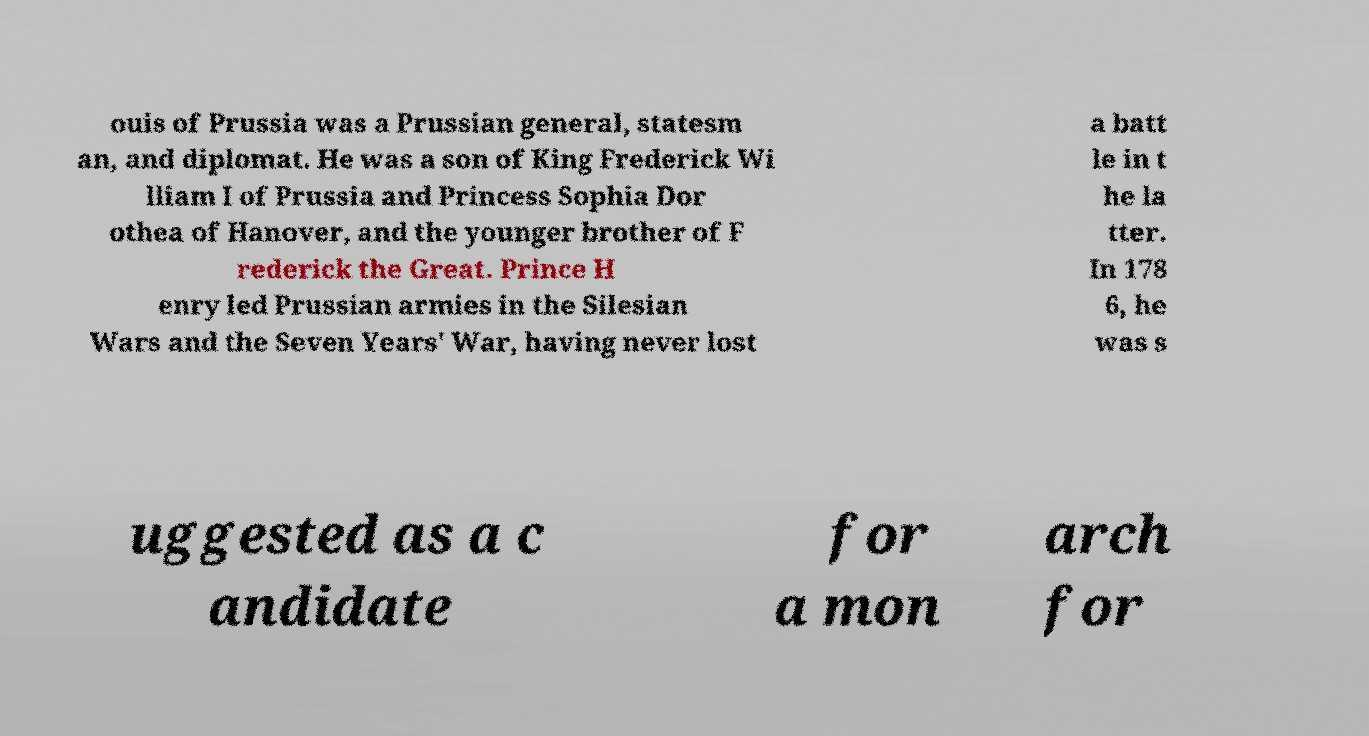Can you accurately transcribe the text from the provided image for me? ouis of Prussia was a Prussian general, statesm an, and diplomat. He was a son of King Frederick Wi lliam I of Prussia and Princess Sophia Dor othea of Hanover, and the younger brother of F rederick the Great. Prince H enry led Prussian armies in the Silesian Wars and the Seven Years' War, having never lost a batt le in t he la tter. In 178 6, he was s uggested as a c andidate for a mon arch for 